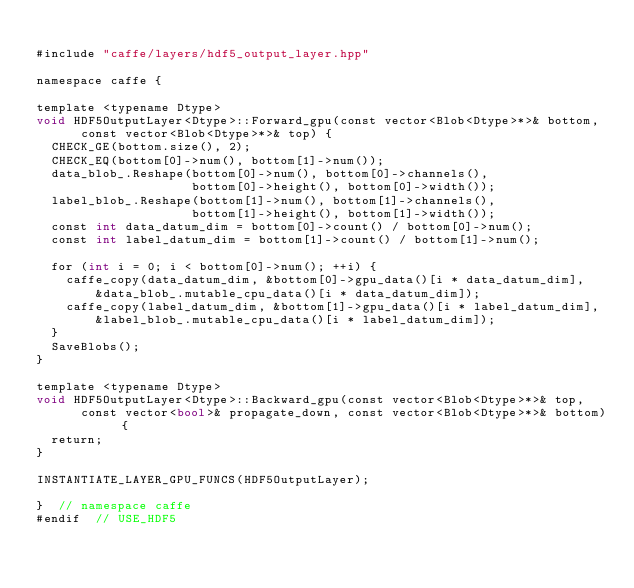Convert code to text. <code><loc_0><loc_0><loc_500><loc_500><_Cuda_>
#include "caffe/layers/hdf5_output_layer.hpp"

namespace caffe {

template <typename Dtype>
void HDF5OutputLayer<Dtype>::Forward_gpu(const vector<Blob<Dtype>*>& bottom,
      const vector<Blob<Dtype>*>& top) {
  CHECK_GE(bottom.size(), 2);
  CHECK_EQ(bottom[0]->num(), bottom[1]->num());
  data_blob_.Reshape(bottom[0]->num(), bottom[0]->channels(),
                     bottom[0]->height(), bottom[0]->width());
  label_blob_.Reshape(bottom[1]->num(), bottom[1]->channels(),
                     bottom[1]->height(), bottom[1]->width());
  const int data_datum_dim = bottom[0]->count() / bottom[0]->num();
  const int label_datum_dim = bottom[1]->count() / bottom[1]->num();

  for (int i = 0; i < bottom[0]->num(); ++i) {
    caffe_copy(data_datum_dim, &bottom[0]->gpu_data()[i * data_datum_dim],
        &data_blob_.mutable_cpu_data()[i * data_datum_dim]);
    caffe_copy(label_datum_dim, &bottom[1]->gpu_data()[i * label_datum_dim],
        &label_blob_.mutable_cpu_data()[i * label_datum_dim]);
  }
  SaveBlobs();
}

template <typename Dtype>
void HDF5OutputLayer<Dtype>::Backward_gpu(const vector<Blob<Dtype>*>& top,
      const vector<bool>& propagate_down, const vector<Blob<Dtype>*>& bottom) {
  return;
}

INSTANTIATE_LAYER_GPU_FUNCS(HDF5OutputLayer);

}  // namespace caffe
#endif  // USE_HDF5
</code> 